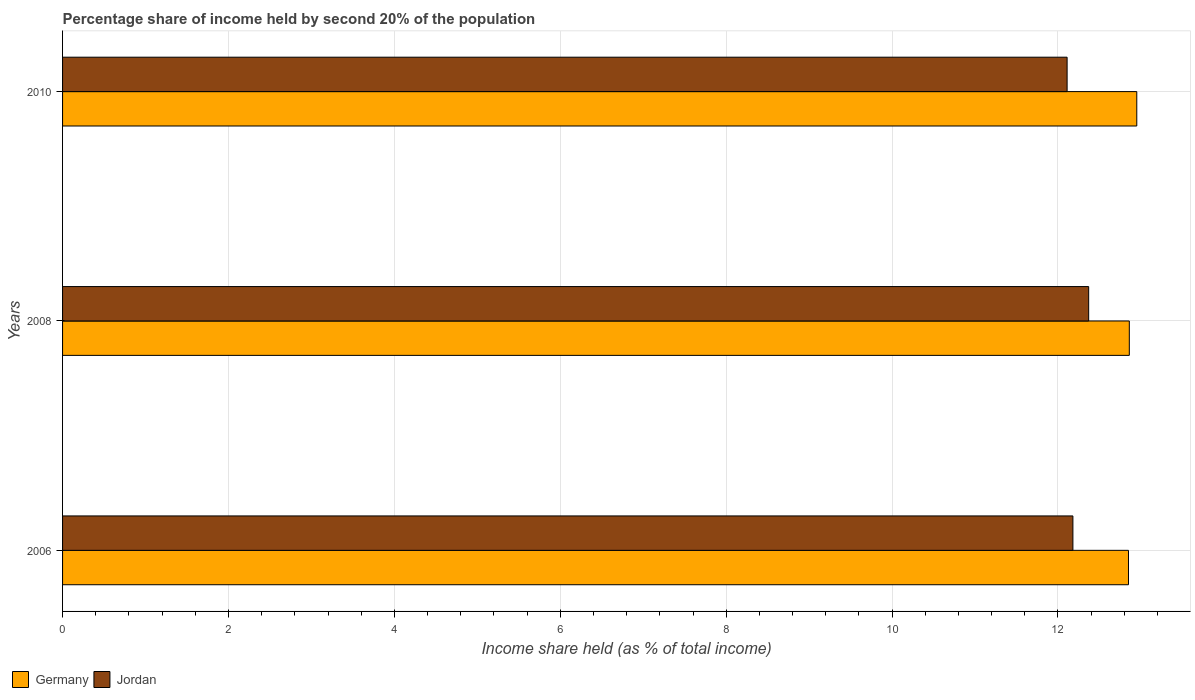How many different coloured bars are there?
Provide a succinct answer. 2. Are the number of bars per tick equal to the number of legend labels?
Keep it short and to the point. Yes. How many bars are there on the 3rd tick from the top?
Offer a very short reply. 2. How many bars are there on the 3rd tick from the bottom?
Ensure brevity in your answer.  2. What is the label of the 1st group of bars from the top?
Keep it short and to the point. 2010. What is the share of income held by second 20% of the population in Germany in 2008?
Give a very brief answer. 12.86. Across all years, what is the maximum share of income held by second 20% of the population in Jordan?
Ensure brevity in your answer.  12.37. Across all years, what is the minimum share of income held by second 20% of the population in Germany?
Keep it short and to the point. 12.85. In which year was the share of income held by second 20% of the population in Germany minimum?
Your answer should be very brief. 2006. What is the total share of income held by second 20% of the population in Germany in the graph?
Your answer should be compact. 38.66. What is the difference between the share of income held by second 20% of the population in Germany in 2006 and that in 2010?
Your answer should be compact. -0.1. What is the difference between the share of income held by second 20% of the population in Jordan in 2010 and the share of income held by second 20% of the population in Germany in 2008?
Ensure brevity in your answer.  -0.75. What is the average share of income held by second 20% of the population in Germany per year?
Provide a short and direct response. 12.89. In the year 2006, what is the difference between the share of income held by second 20% of the population in Jordan and share of income held by second 20% of the population in Germany?
Keep it short and to the point. -0.67. In how many years, is the share of income held by second 20% of the population in Jordan greater than 8 %?
Make the answer very short. 3. What is the ratio of the share of income held by second 20% of the population in Germany in 2006 to that in 2010?
Make the answer very short. 0.99. Is the share of income held by second 20% of the population in Jordan in 2006 less than that in 2008?
Provide a succinct answer. Yes. Is the difference between the share of income held by second 20% of the population in Jordan in 2006 and 2010 greater than the difference between the share of income held by second 20% of the population in Germany in 2006 and 2010?
Provide a succinct answer. Yes. What is the difference between the highest and the second highest share of income held by second 20% of the population in Jordan?
Your response must be concise. 0.19. What is the difference between the highest and the lowest share of income held by second 20% of the population in Jordan?
Your answer should be compact. 0.26. What does the 1st bar from the top in 2010 represents?
Make the answer very short. Jordan. How many bars are there?
Keep it short and to the point. 6. How many years are there in the graph?
Ensure brevity in your answer.  3. What is the difference between two consecutive major ticks on the X-axis?
Your answer should be very brief. 2. Are the values on the major ticks of X-axis written in scientific E-notation?
Offer a very short reply. No. Does the graph contain any zero values?
Provide a short and direct response. No. Does the graph contain grids?
Keep it short and to the point. Yes. Where does the legend appear in the graph?
Provide a succinct answer. Bottom left. How many legend labels are there?
Make the answer very short. 2. What is the title of the graph?
Your response must be concise. Percentage share of income held by second 20% of the population. What is the label or title of the X-axis?
Ensure brevity in your answer.  Income share held (as % of total income). What is the label or title of the Y-axis?
Your answer should be very brief. Years. What is the Income share held (as % of total income) of Germany in 2006?
Keep it short and to the point. 12.85. What is the Income share held (as % of total income) in Jordan in 2006?
Your response must be concise. 12.18. What is the Income share held (as % of total income) of Germany in 2008?
Provide a short and direct response. 12.86. What is the Income share held (as % of total income) in Jordan in 2008?
Keep it short and to the point. 12.37. What is the Income share held (as % of total income) of Germany in 2010?
Offer a terse response. 12.95. What is the Income share held (as % of total income) of Jordan in 2010?
Give a very brief answer. 12.11. Across all years, what is the maximum Income share held (as % of total income) of Germany?
Ensure brevity in your answer.  12.95. Across all years, what is the maximum Income share held (as % of total income) of Jordan?
Give a very brief answer. 12.37. Across all years, what is the minimum Income share held (as % of total income) in Germany?
Offer a very short reply. 12.85. Across all years, what is the minimum Income share held (as % of total income) of Jordan?
Ensure brevity in your answer.  12.11. What is the total Income share held (as % of total income) in Germany in the graph?
Make the answer very short. 38.66. What is the total Income share held (as % of total income) of Jordan in the graph?
Offer a very short reply. 36.66. What is the difference between the Income share held (as % of total income) in Germany in 2006 and that in 2008?
Keep it short and to the point. -0.01. What is the difference between the Income share held (as % of total income) of Jordan in 2006 and that in 2008?
Your answer should be very brief. -0.19. What is the difference between the Income share held (as % of total income) in Jordan in 2006 and that in 2010?
Provide a succinct answer. 0.07. What is the difference between the Income share held (as % of total income) of Germany in 2008 and that in 2010?
Give a very brief answer. -0.09. What is the difference between the Income share held (as % of total income) of Jordan in 2008 and that in 2010?
Make the answer very short. 0.26. What is the difference between the Income share held (as % of total income) of Germany in 2006 and the Income share held (as % of total income) of Jordan in 2008?
Your answer should be very brief. 0.48. What is the difference between the Income share held (as % of total income) of Germany in 2006 and the Income share held (as % of total income) of Jordan in 2010?
Give a very brief answer. 0.74. What is the difference between the Income share held (as % of total income) in Germany in 2008 and the Income share held (as % of total income) in Jordan in 2010?
Offer a very short reply. 0.75. What is the average Income share held (as % of total income) in Germany per year?
Offer a very short reply. 12.89. What is the average Income share held (as % of total income) in Jordan per year?
Your response must be concise. 12.22. In the year 2006, what is the difference between the Income share held (as % of total income) in Germany and Income share held (as % of total income) in Jordan?
Your answer should be compact. 0.67. In the year 2008, what is the difference between the Income share held (as % of total income) in Germany and Income share held (as % of total income) in Jordan?
Give a very brief answer. 0.49. In the year 2010, what is the difference between the Income share held (as % of total income) of Germany and Income share held (as % of total income) of Jordan?
Your answer should be very brief. 0.84. What is the ratio of the Income share held (as % of total income) in Germany in 2006 to that in 2008?
Your answer should be very brief. 1. What is the ratio of the Income share held (as % of total income) in Jordan in 2006 to that in 2008?
Provide a succinct answer. 0.98. What is the ratio of the Income share held (as % of total income) in Jordan in 2006 to that in 2010?
Provide a succinct answer. 1.01. What is the ratio of the Income share held (as % of total income) in Germany in 2008 to that in 2010?
Your answer should be very brief. 0.99. What is the ratio of the Income share held (as % of total income) of Jordan in 2008 to that in 2010?
Make the answer very short. 1.02. What is the difference between the highest and the second highest Income share held (as % of total income) of Germany?
Provide a short and direct response. 0.09. What is the difference between the highest and the second highest Income share held (as % of total income) in Jordan?
Your answer should be compact. 0.19. What is the difference between the highest and the lowest Income share held (as % of total income) of Jordan?
Offer a terse response. 0.26. 